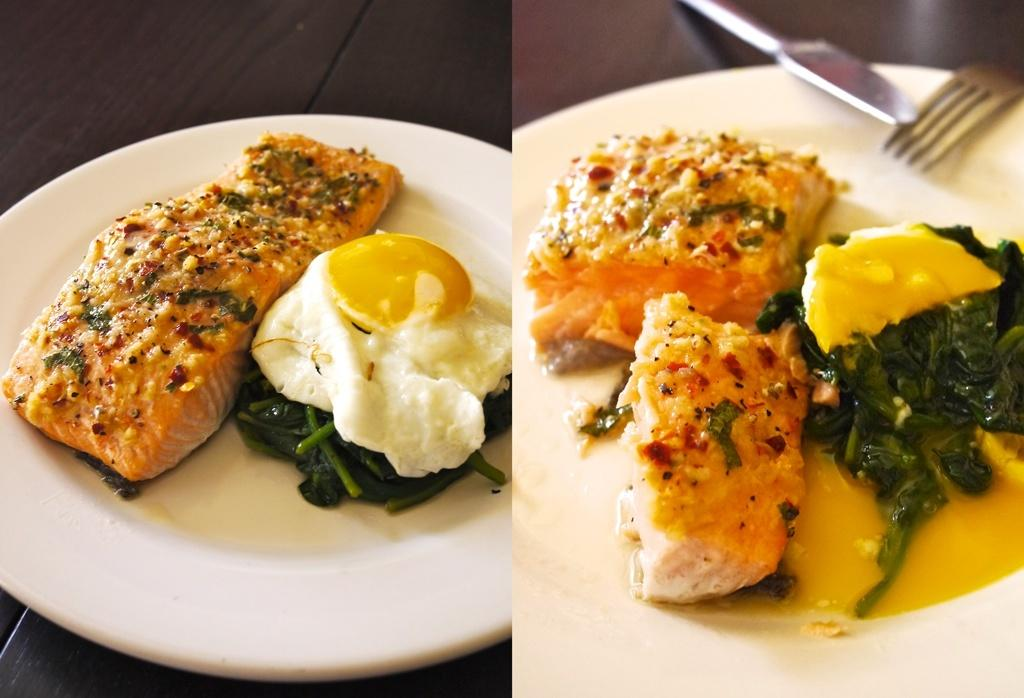What type of items are featured in the collage in the image? The image contains a collage of food items. What utensils are visible in the image? There is a fork and a knife in the image. What objects are used for serving food in the image? There are plates in the image. Where are the plates located in the image? The plates are on a table. Can you see a receipt for the food items in the image? There is no receipt present in the image; it features a collage of food items, utensils, and plates. Is there a pipe visible in the image? There is no pipe present in the image. 